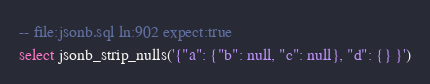<code> <loc_0><loc_0><loc_500><loc_500><_SQL_>-- file:jsonb.sql ln:902 expect:true
select jsonb_strip_nulls('{"a": {"b": null, "c": null}, "d": {} }')
</code> 